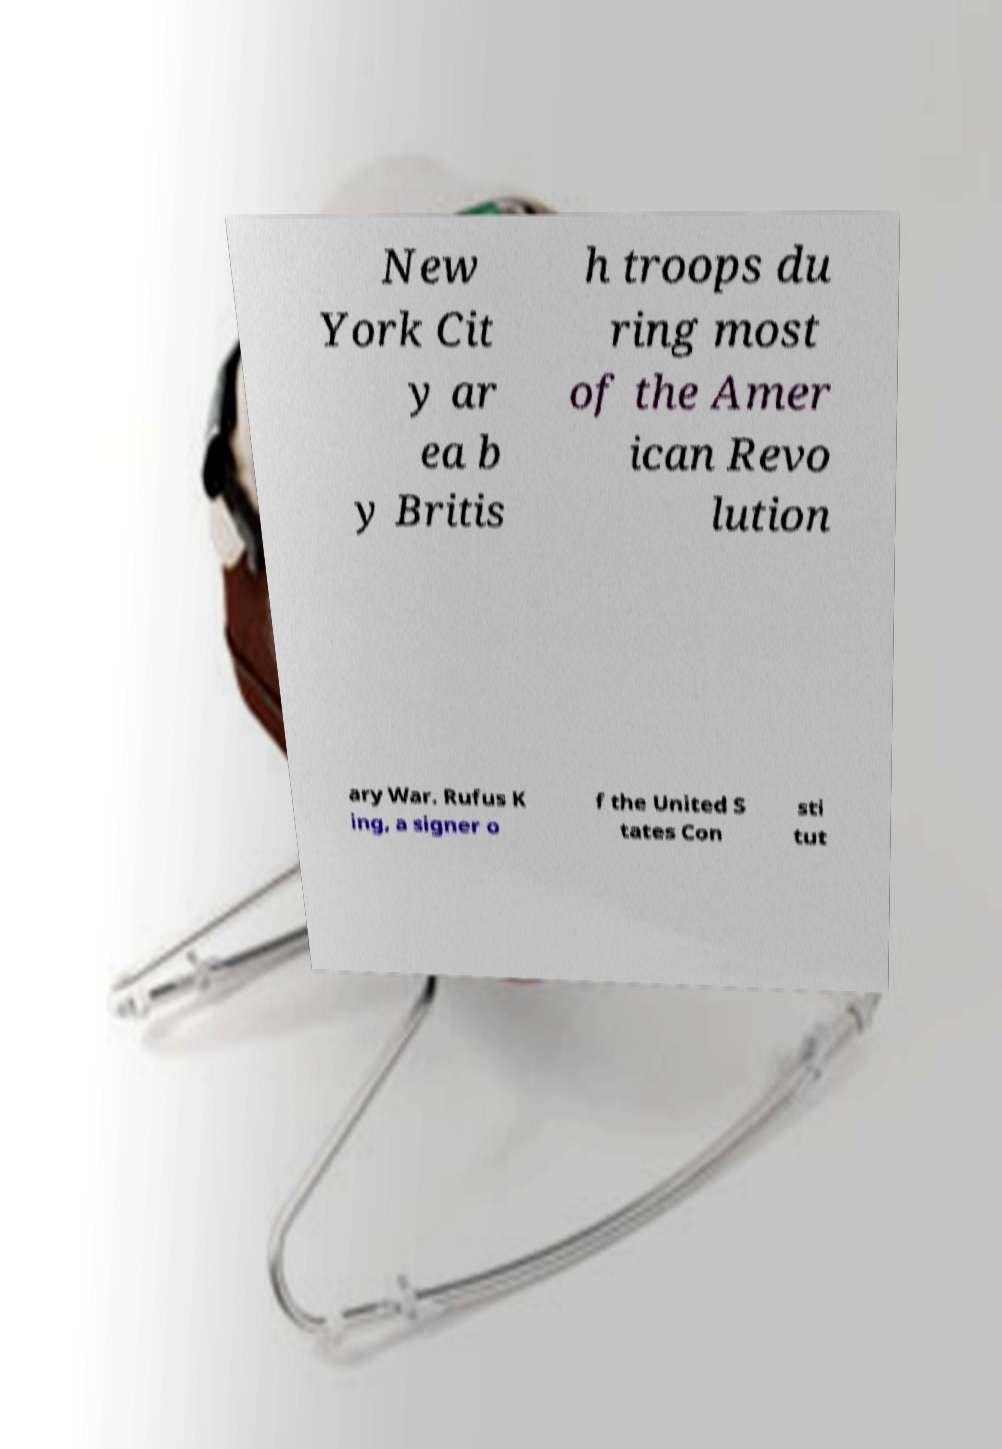Can you accurately transcribe the text from the provided image for me? New York Cit y ar ea b y Britis h troops du ring most of the Amer ican Revo lution ary War. Rufus K ing, a signer o f the United S tates Con sti tut 